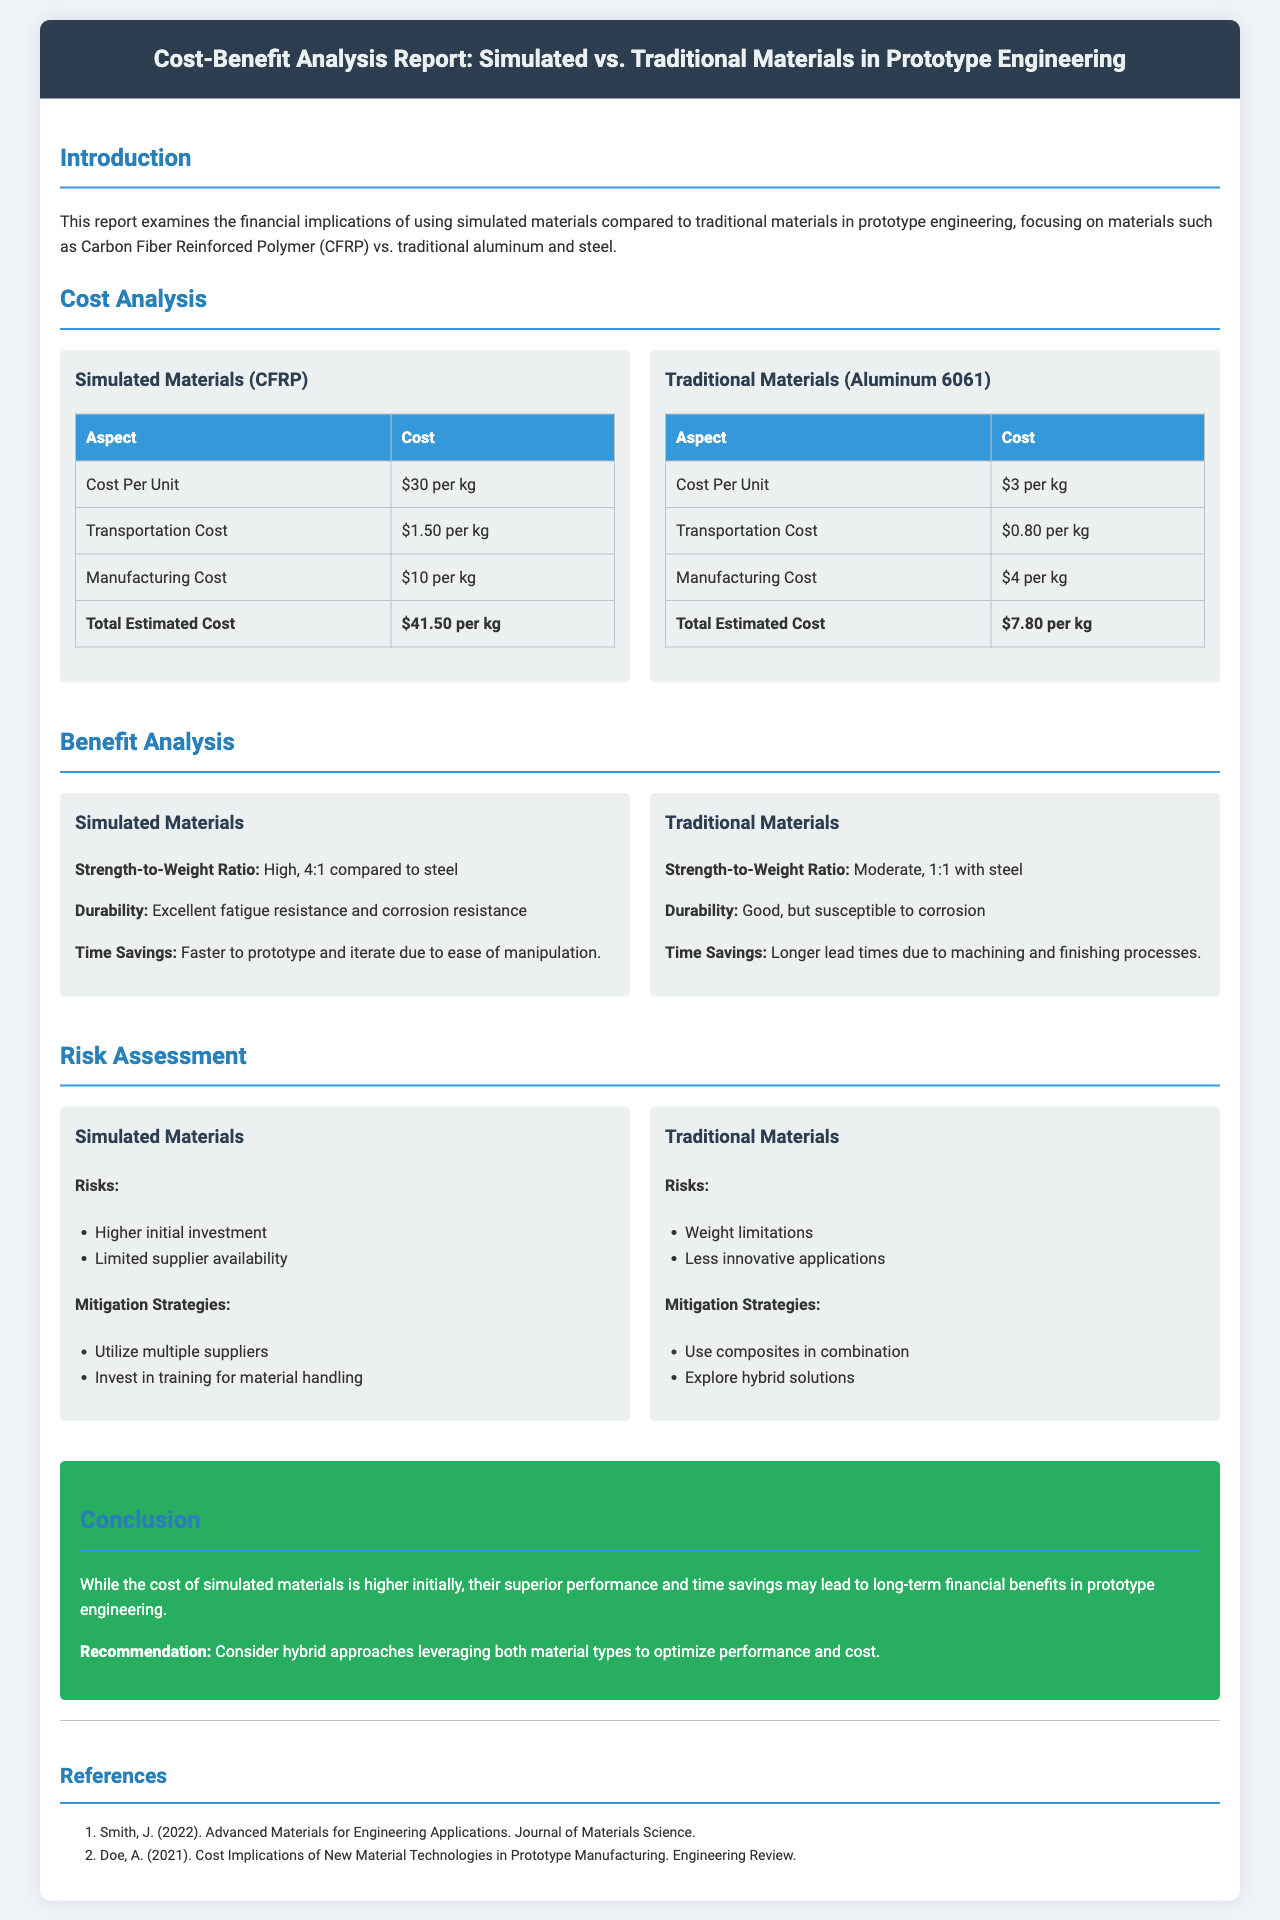What is the cost per unit of simulated materials? The cost per unit of simulated materials (CFRP) is stated in the document.
Answer: $30 per kg What is the total estimated cost for traditional materials? The total estimated cost for traditional materials (Aluminum 6061) is calculated based on its components.
Answer: $7.80 per kg What is the strength-to-weight ratio of simulated materials? The strength-to-weight ratio of simulated materials is compared to that of steel and mentioned in the benefits section.
Answer: High, 4:1 What risk is associated with using traditional materials? The document lists several risks related to traditional materials in the risk assessment section.
Answer: Weight limitations Which mitigation strategy is suggested for simulated materials? The document describes mitigation strategies for risks associated with simulated materials.
Answer: Utilize multiple suppliers What is the main conclusion of the report? The conclusion summarizes the report's findings regarding the costs and benefits of materials.
Answer: Superior performance and time savings What is the manufacturing cost of simulated materials? The manufacturing cost of simulated materials is provided in the cost analysis section.
Answer: $10 per kg Who authored the reference on advanced materials? The references section lists authors for the cited works within the text.
Answer: Smith, J What is recommended for optimizing performance and cost? The conclusion offers a recommendation to balance material types for better outcomes.
Answer: Hybrid approaches 